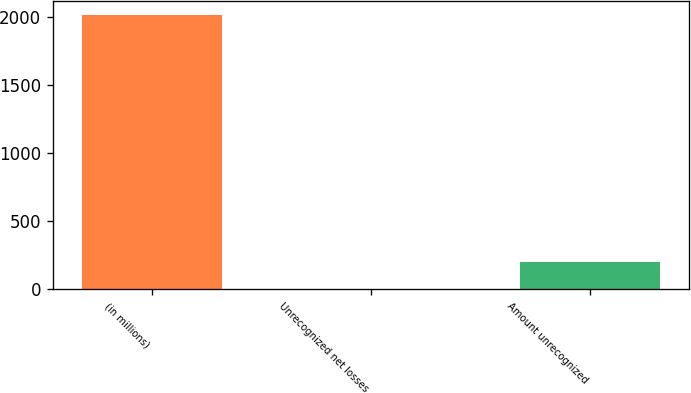Convert chart. <chart><loc_0><loc_0><loc_500><loc_500><bar_chart><fcel>(in millions)<fcel>Unrecognized net losses<fcel>Amount unrecognized<nl><fcel>2013<fcel>1<fcel>202.2<nl></chart> 